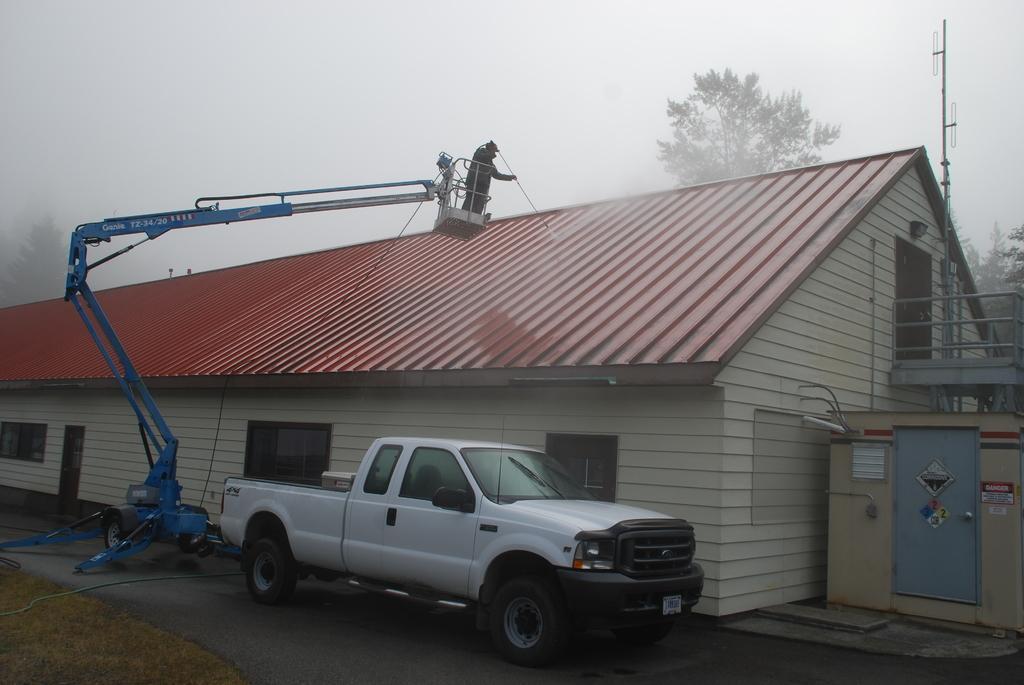Please provide a concise description of this image. In the picture we can see a house, shed with windows and door and near to it, we can see a car which is white in color with a trailer and some crane on the wheels and a person standing on it and doing some repair to the roof and behind we can see some trees and sky with clouds. 